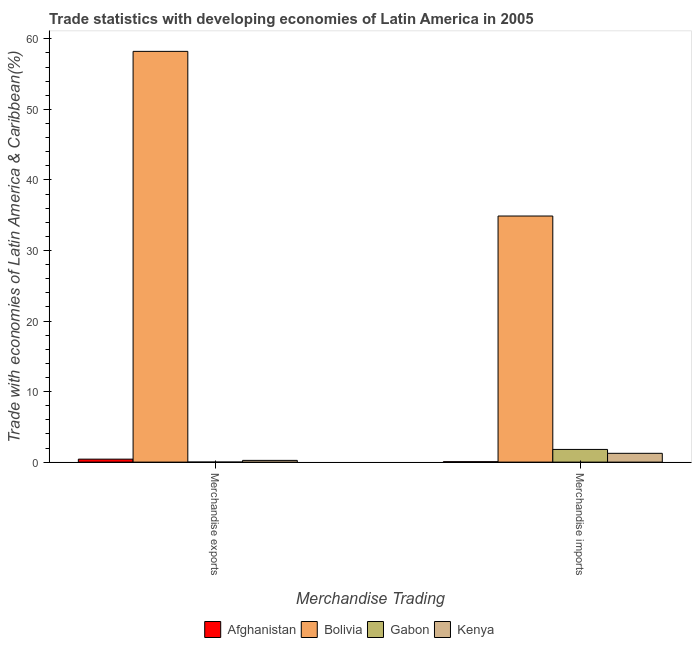How many groups of bars are there?
Offer a very short reply. 2. Are the number of bars per tick equal to the number of legend labels?
Ensure brevity in your answer.  Yes. Are the number of bars on each tick of the X-axis equal?
Keep it short and to the point. Yes. How many bars are there on the 2nd tick from the left?
Your answer should be very brief. 4. What is the merchandise imports in Bolivia?
Offer a terse response. 34.89. Across all countries, what is the maximum merchandise imports?
Your response must be concise. 34.89. Across all countries, what is the minimum merchandise exports?
Ensure brevity in your answer.  0. In which country was the merchandise exports minimum?
Keep it short and to the point. Gabon. What is the total merchandise imports in the graph?
Make the answer very short. 38. What is the difference between the merchandise exports in Bolivia and that in Gabon?
Make the answer very short. 58.23. What is the difference between the merchandise exports in Gabon and the merchandise imports in Afghanistan?
Offer a terse response. -0.06. What is the average merchandise imports per country?
Provide a succinct answer. 9.5. What is the difference between the merchandise imports and merchandise exports in Afghanistan?
Provide a short and direct response. -0.36. What is the ratio of the merchandise imports in Gabon to that in Afghanistan?
Keep it short and to the point. 30.44. What does the 3rd bar from the left in Merchandise imports represents?
Offer a very short reply. Gabon. What does the 3rd bar from the right in Merchandise exports represents?
Your answer should be compact. Bolivia. How are the legend labels stacked?
Ensure brevity in your answer.  Horizontal. What is the title of the graph?
Offer a terse response. Trade statistics with developing economies of Latin America in 2005. What is the label or title of the X-axis?
Your response must be concise. Merchandise Trading. What is the label or title of the Y-axis?
Offer a terse response. Trade with economies of Latin America & Caribbean(%). What is the Trade with economies of Latin America & Caribbean(%) of Afghanistan in Merchandise exports?
Your response must be concise. 0.42. What is the Trade with economies of Latin America & Caribbean(%) in Bolivia in Merchandise exports?
Make the answer very short. 58.23. What is the Trade with economies of Latin America & Caribbean(%) in Gabon in Merchandise exports?
Make the answer very short. 0. What is the Trade with economies of Latin America & Caribbean(%) of Kenya in Merchandise exports?
Provide a short and direct response. 0.25. What is the Trade with economies of Latin America & Caribbean(%) of Afghanistan in Merchandise imports?
Offer a terse response. 0.06. What is the Trade with economies of Latin America & Caribbean(%) of Bolivia in Merchandise imports?
Your answer should be compact. 34.89. What is the Trade with economies of Latin America & Caribbean(%) of Gabon in Merchandise imports?
Your response must be concise. 1.8. What is the Trade with economies of Latin America & Caribbean(%) of Kenya in Merchandise imports?
Your response must be concise. 1.25. Across all Merchandise Trading, what is the maximum Trade with economies of Latin America & Caribbean(%) in Afghanistan?
Ensure brevity in your answer.  0.42. Across all Merchandise Trading, what is the maximum Trade with economies of Latin America & Caribbean(%) of Bolivia?
Provide a short and direct response. 58.23. Across all Merchandise Trading, what is the maximum Trade with economies of Latin America & Caribbean(%) of Gabon?
Give a very brief answer. 1.8. Across all Merchandise Trading, what is the maximum Trade with economies of Latin America & Caribbean(%) of Kenya?
Your response must be concise. 1.25. Across all Merchandise Trading, what is the minimum Trade with economies of Latin America & Caribbean(%) of Afghanistan?
Offer a very short reply. 0.06. Across all Merchandise Trading, what is the minimum Trade with economies of Latin America & Caribbean(%) in Bolivia?
Ensure brevity in your answer.  34.89. Across all Merchandise Trading, what is the minimum Trade with economies of Latin America & Caribbean(%) in Gabon?
Your answer should be very brief. 0. Across all Merchandise Trading, what is the minimum Trade with economies of Latin America & Caribbean(%) of Kenya?
Offer a terse response. 0.25. What is the total Trade with economies of Latin America & Caribbean(%) of Afghanistan in the graph?
Provide a short and direct response. 0.48. What is the total Trade with economies of Latin America & Caribbean(%) of Bolivia in the graph?
Ensure brevity in your answer.  93.12. What is the total Trade with economies of Latin America & Caribbean(%) of Gabon in the graph?
Give a very brief answer. 1.8. What is the total Trade with economies of Latin America & Caribbean(%) of Kenya in the graph?
Offer a very short reply. 1.49. What is the difference between the Trade with economies of Latin America & Caribbean(%) in Afghanistan in Merchandise exports and that in Merchandise imports?
Your answer should be very brief. 0.36. What is the difference between the Trade with economies of Latin America & Caribbean(%) of Bolivia in Merchandise exports and that in Merchandise imports?
Your answer should be very brief. 23.34. What is the difference between the Trade with economies of Latin America & Caribbean(%) of Gabon in Merchandise exports and that in Merchandise imports?
Provide a short and direct response. -1.8. What is the difference between the Trade with economies of Latin America & Caribbean(%) of Kenya in Merchandise exports and that in Merchandise imports?
Give a very brief answer. -1. What is the difference between the Trade with economies of Latin America & Caribbean(%) of Afghanistan in Merchandise exports and the Trade with economies of Latin America & Caribbean(%) of Bolivia in Merchandise imports?
Keep it short and to the point. -34.47. What is the difference between the Trade with economies of Latin America & Caribbean(%) of Afghanistan in Merchandise exports and the Trade with economies of Latin America & Caribbean(%) of Gabon in Merchandise imports?
Ensure brevity in your answer.  -1.38. What is the difference between the Trade with economies of Latin America & Caribbean(%) in Afghanistan in Merchandise exports and the Trade with economies of Latin America & Caribbean(%) in Kenya in Merchandise imports?
Offer a terse response. -0.83. What is the difference between the Trade with economies of Latin America & Caribbean(%) in Bolivia in Merchandise exports and the Trade with economies of Latin America & Caribbean(%) in Gabon in Merchandise imports?
Ensure brevity in your answer.  56.43. What is the difference between the Trade with economies of Latin America & Caribbean(%) of Bolivia in Merchandise exports and the Trade with economies of Latin America & Caribbean(%) of Kenya in Merchandise imports?
Make the answer very short. 56.98. What is the difference between the Trade with economies of Latin America & Caribbean(%) of Gabon in Merchandise exports and the Trade with economies of Latin America & Caribbean(%) of Kenya in Merchandise imports?
Give a very brief answer. -1.25. What is the average Trade with economies of Latin America & Caribbean(%) in Afghanistan per Merchandise Trading?
Your response must be concise. 0.24. What is the average Trade with economies of Latin America & Caribbean(%) of Bolivia per Merchandise Trading?
Your answer should be very brief. 46.56. What is the average Trade with economies of Latin America & Caribbean(%) of Gabon per Merchandise Trading?
Your answer should be very brief. 0.9. What is the average Trade with economies of Latin America & Caribbean(%) of Kenya per Merchandise Trading?
Ensure brevity in your answer.  0.75. What is the difference between the Trade with economies of Latin America & Caribbean(%) of Afghanistan and Trade with economies of Latin America & Caribbean(%) of Bolivia in Merchandise exports?
Make the answer very short. -57.81. What is the difference between the Trade with economies of Latin America & Caribbean(%) of Afghanistan and Trade with economies of Latin America & Caribbean(%) of Gabon in Merchandise exports?
Your answer should be compact. 0.42. What is the difference between the Trade with economies of Latin America & Caribbean(%) in Afghanistan and Trade with economies of Latin America & Caribbean(%) in Kenya in Merchandise exports?
Offer a terse response. 0.18. What is the difference between the Trade with economies of Latin America & Caribbean(%) in Bolivia and Trade with economies of Latin America & Caribbean(%) in Gabon in Merchandise exports?
Your answer should be very brief. 58.23. What is the difference between the Trade with economies of Latin America & Caribbean(%) in Bolivia and Trade with economies of Latin America & Caribbean(%) in Kenya in Merchandise exports?
Provide a succinct answer. 57.98. What is the difference between the Trade with economies of Latin America & Caribbean(%) of Gabon and Trade with economies of Latin America & Caribbean(%) of Kenya in Merchandise exports?
Give a very brief answer. -0.24. What is the difference between the Trade with economies of Latin America & Caribbean(%) of Afghanistan and Trade with economies of Latin America & Caribbean(%) of Bolivia in Merchandise imports?
Provide a succinct answer. -34.83. What is the difference between the Trade with economies of Latin America & Caribbean(%) in Afghanistan and Trade with economies of Latin America & Caribbean(%) in Gabon in Merchandise imports?
Ensure brevity in your answer.  -1.74. What is the difference between the Trade with economies of Latin America & Caribbean(%) of Afghanistan and Trade with economies of Latin America & Caribbean(%) of Kenya in Merchandise imports?
Provide a short and direct response. -1.19. What is the difference between the Trade with economies of Latin America & Caribbean(%) in Bolivia and Trade with economies of Latin America & Caribbean(%) in Gabon in Merchandise imports?
Provide a short and direct response. 33.09. What is the difference between the Trade with economies of Latin America & Caribbean(%) of Bolivia and Trade with economies of Latin America & Caribbean(%) of Kenya in Merchandise imports?
Give a very brief answer. 33.64. What is the difference between the Trade with economies of Latin America & Caribbean(%) in Gabon and Trade with economies of Latin America & Caribbean(%) in Kenya in Merchandise imports?
Provide a short and direct response. 0.55. What is the ratio of the Trade with economies of Latin America & Caribbean(%) of Afghanistan in Merchandise exports to that in Merchandise imports?
Give a very brief answer. 7.13. What is the ratio of the Trade with economies of Latin America & Caribbean(%) of Bolivia in Merchandise exports to that in Merchandise imports?
Make the answer very short. 1.67. What is the ratio of the Trade with economies of Latin America & Caribbean(%) of Gabon in Merchandise exports to that in Merchandise imports?
Keep it short and to the point. 0. What is the ratio of the Trade with economies of Latin America & Caribbean(%) of Kenya in Merchandise exports to that in Merchandise imports?
Provide a succinct answer. 0.2. What is the difference between the highest and the second highest Trade with economies of Latin America & Caribbean(%) in Afghanistan?
Your answer should be compact. 0.36. What is the difference between the highest and the second highest Trade with economies of Latin America & Caribbean(%) in Bolivia?
Keep it short and to the point. 23.34. What is the difference between the highest and the second highest Trade with economies of Latin America & Caribbean(%) of Gabon?
Your response must be concise. 1.8. What is the difference between the highest and the second highest Trade with economies of Latin America & Caribbean(%) of Kenya?
Your answer should be very brief. 1. What is the difference between the highest and the lowest Trade with economies of Latin America & Caribbean(%) in Afghanistan?
Provide a short and direct response. 0.36. What is the difference between the highest and the lowest Trade with economies of Latin America & Caribbean(%) in Bolivia?
Keep it short and to the point. 23.34. What is the difference between the highest and the lowest Trade with economies of Latin America & Caribbean(%) in Gabon?
Your response must be concise. 1.8. What is the difference between the highest and the lowest Trade with economies of Latin America & Caribbean(%) in Kenya?
Provide a succinct answer. 1. 